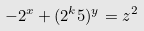<formula> <loc_0><loc_0><loc_500><loc_500>- 2 ^ { x } + ( 2 ^ { k } 5 ) ^ { y } = z ^ { 2 }</formula> 